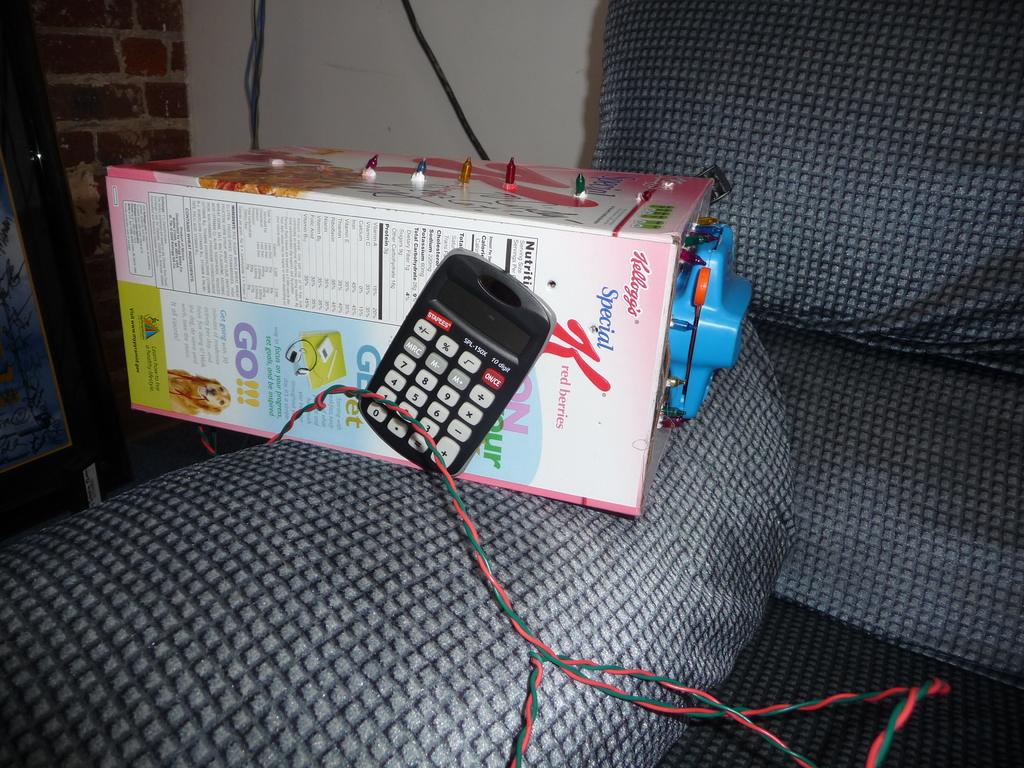What cereal is shown?
Offer a terse response. Special k. What is the word in purple capital letters?
Offer a very short reply. Go. 